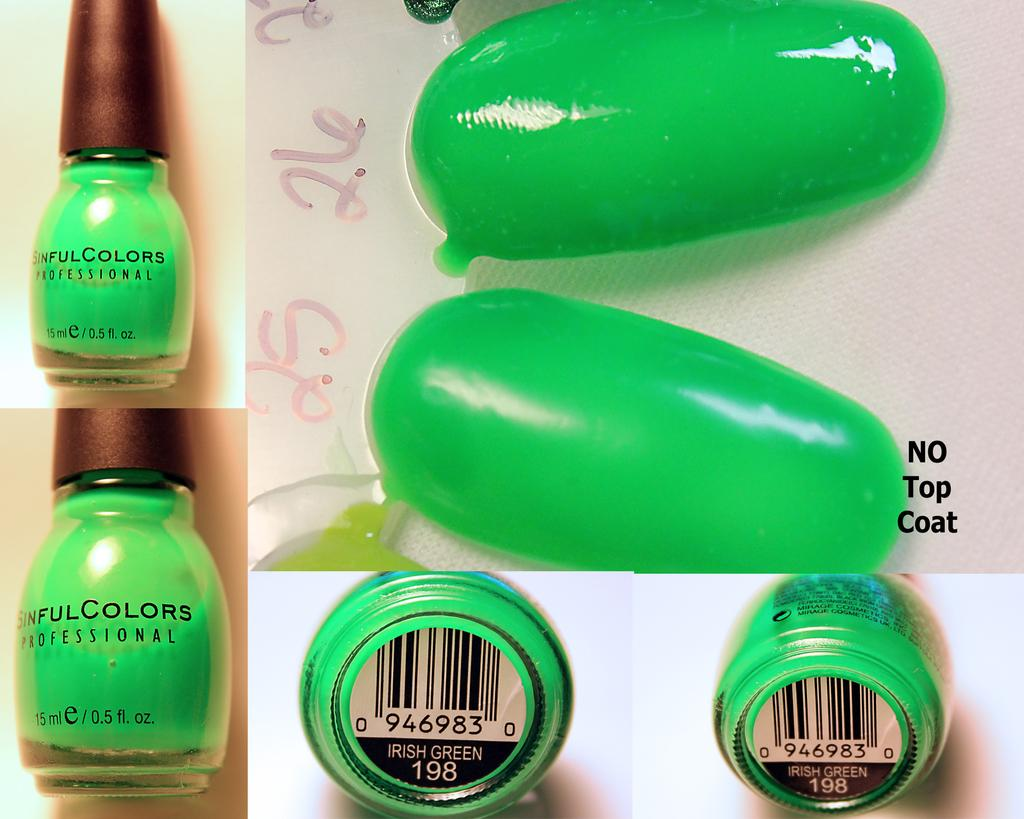<image>
Relay a brief, clear account of the picture shown. A collage featuring Sinful Colors irish green nail polish. 